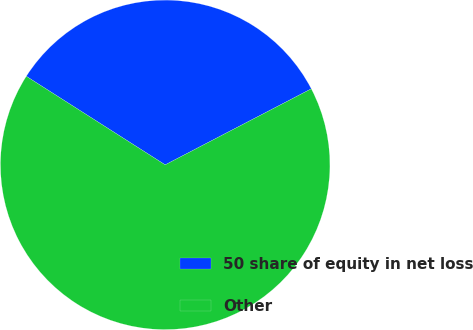<chart> <loc_0><loc_0><loc_500><loc_500><pie_chart><fcel>50 share of equity in net loss<fcel>Other<nl><fcel>33.33%<fcel>66.67%<nl></chart> 